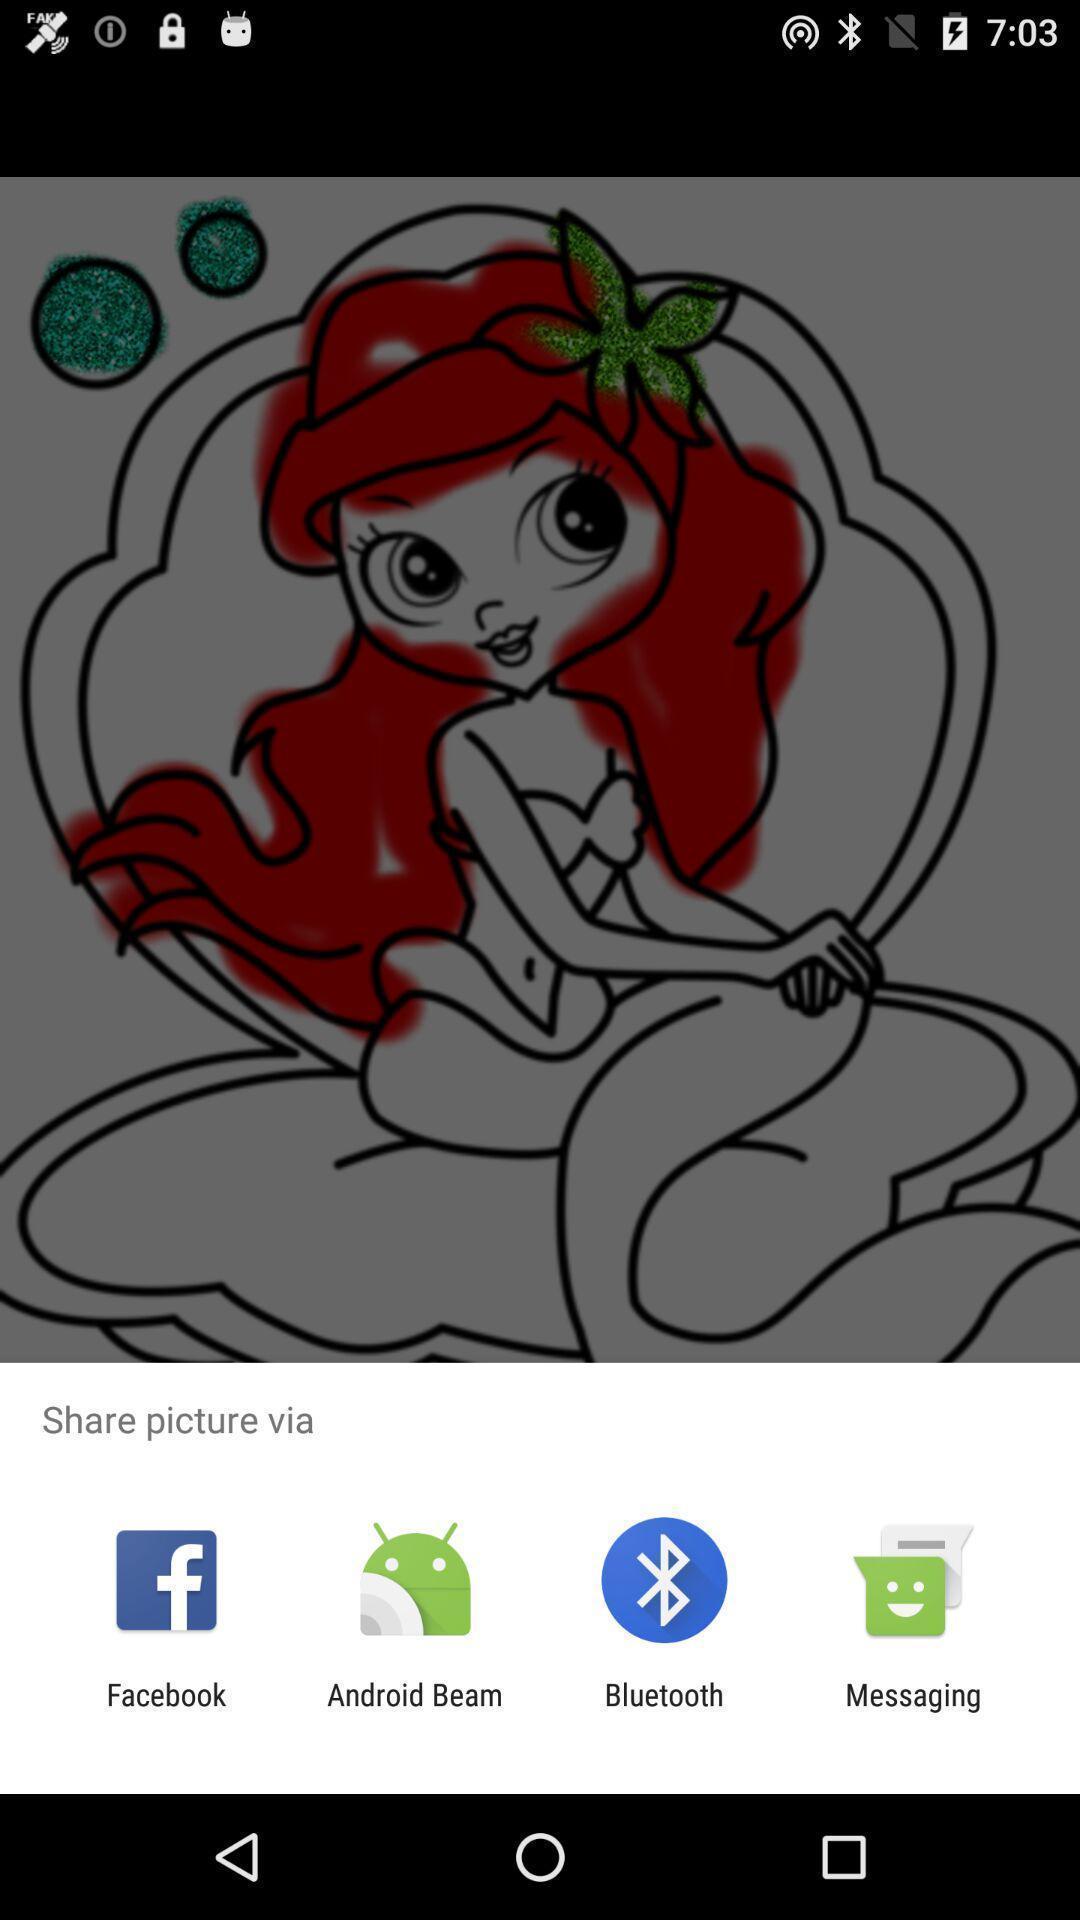Explain the elements present in this screenshot. Popup to share picture for the painting app. 